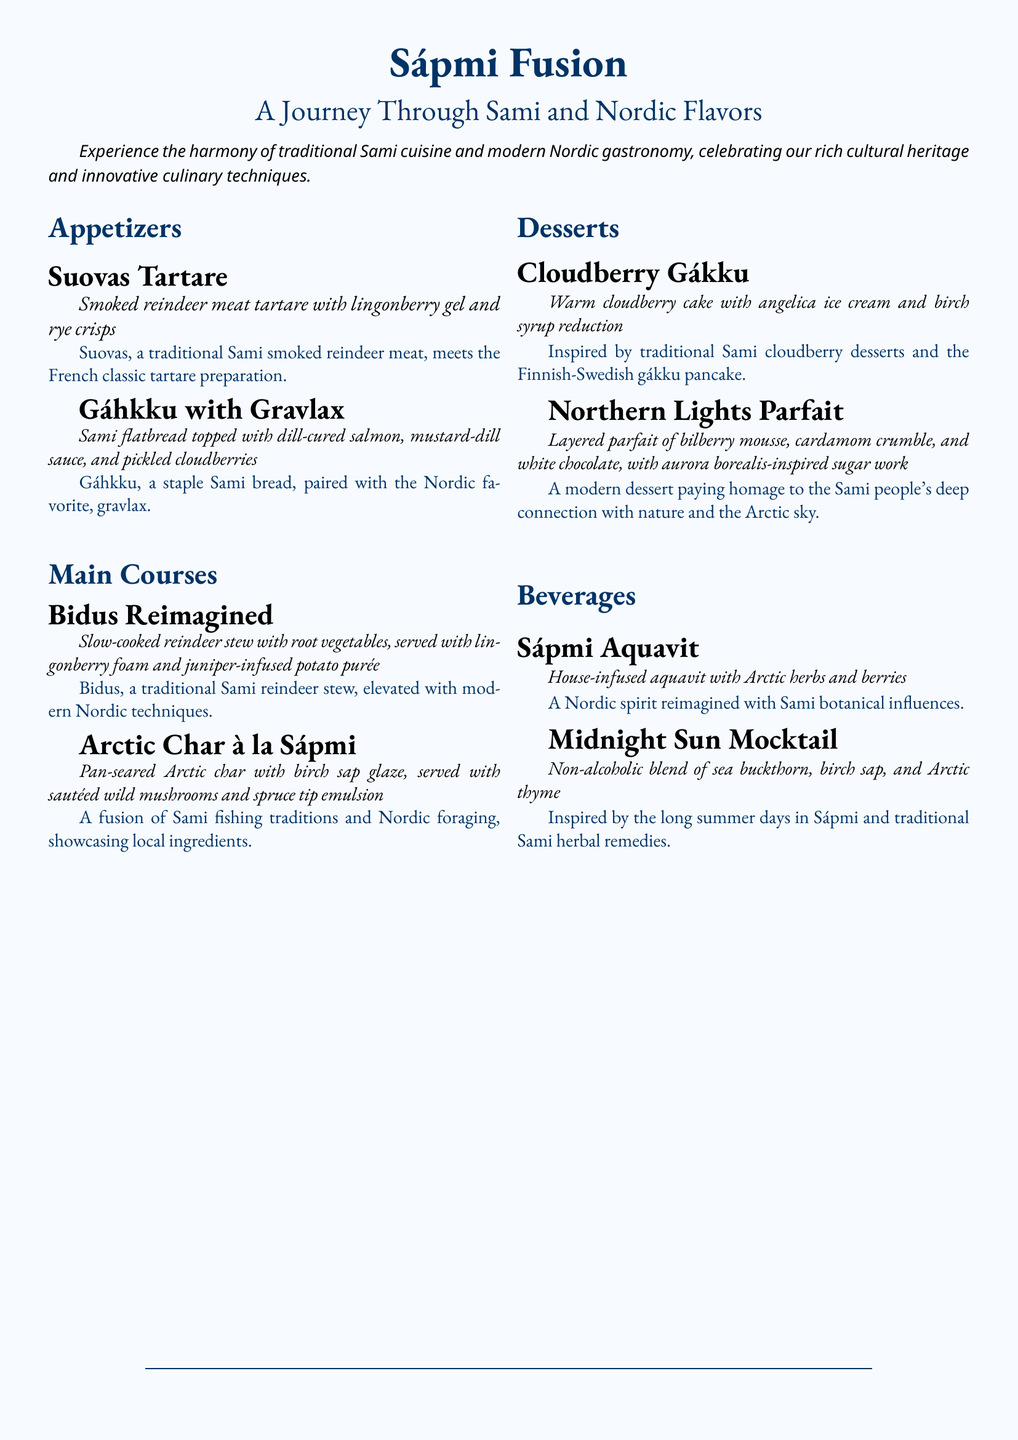What is the name of the first appetizer? The first appetizer listed is Suovas Tartare.
Answer: Suovas Tartare What dish features cloudberries in the main courses? The dish featuring cloudberries is Bidus Reimagined.
Answer: Bidus Reimagined How many desserts are on the menu? There are two desserts listed on the menu.
Answer: 2 What type of spirit is the Sápmi Aquavit? The Sápmi Aquavit is a house-infused aquavit.
Answer: House-infused aquavit What culinary technique is mentioned in the Bidus Reimagined dish? The technique mentioned is slow-cooked.
Answer: Slow-cooked What is the main ingredient of the Northern Lights Parfait? The main ingredient of the Northern Lights Parfait is bilberry mousse.
Answer: Bilberry mousse Which drink is inspired by traditional Sami herbal remedies? The drink inspired by traditional Sami herbal remedies is Midnight Sun Mocktail.
Answer: Midnight Sun Mocktail What two regions' cuisines are being fused in the menu? The cuisines being fused are Sami and Nordic.
Answer: Sami and Nordic 